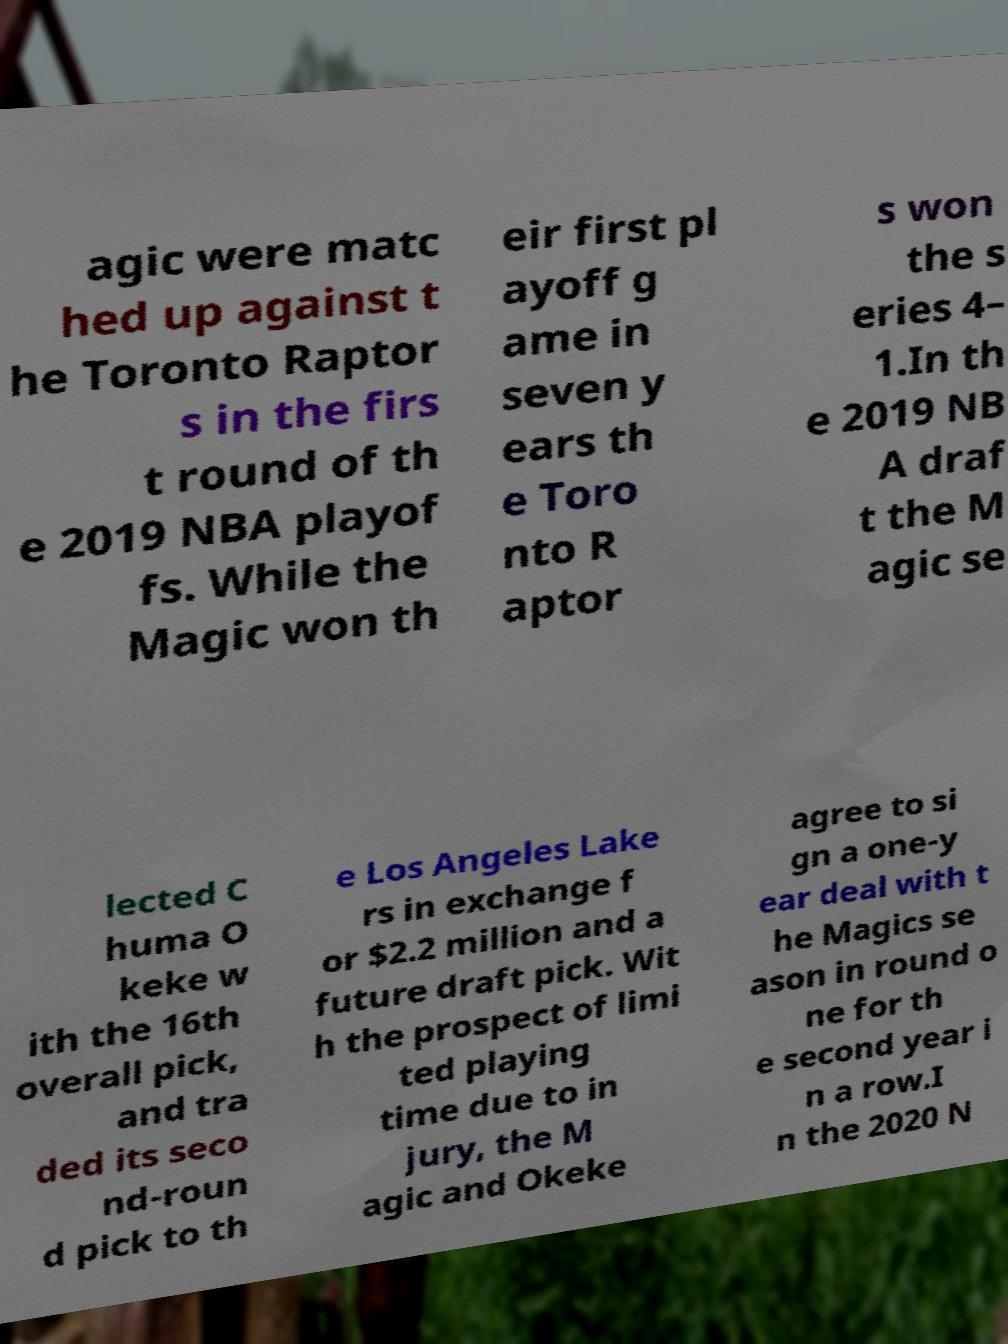There's text embedded in this image that I need extracted. Can you transcribe it verbatim? agic were matc hed up against t he Toronto Raptor s in the firs t round of th e 2019 NBA playof fs. While the Magic won th eir first pl ayoff g ame in seven y ears th e Toro nto R aptor s won the s eries 4– 1.In th e 2019 NB A draf t the M agic se lected C huma O keke w ith the 16th overall pick, and tra ded its seco nd-roun d pick to th e Los Angeles Lake rs in exchange f or $2.2 million and a future draft pick. Wit h the prospect of limi ted playing time due to in jury, the M agic and Okeke agree to si gn a one-y ear deal with t he Magics se ason in round o ne for th e second year i n a row.I n the 2020 N 